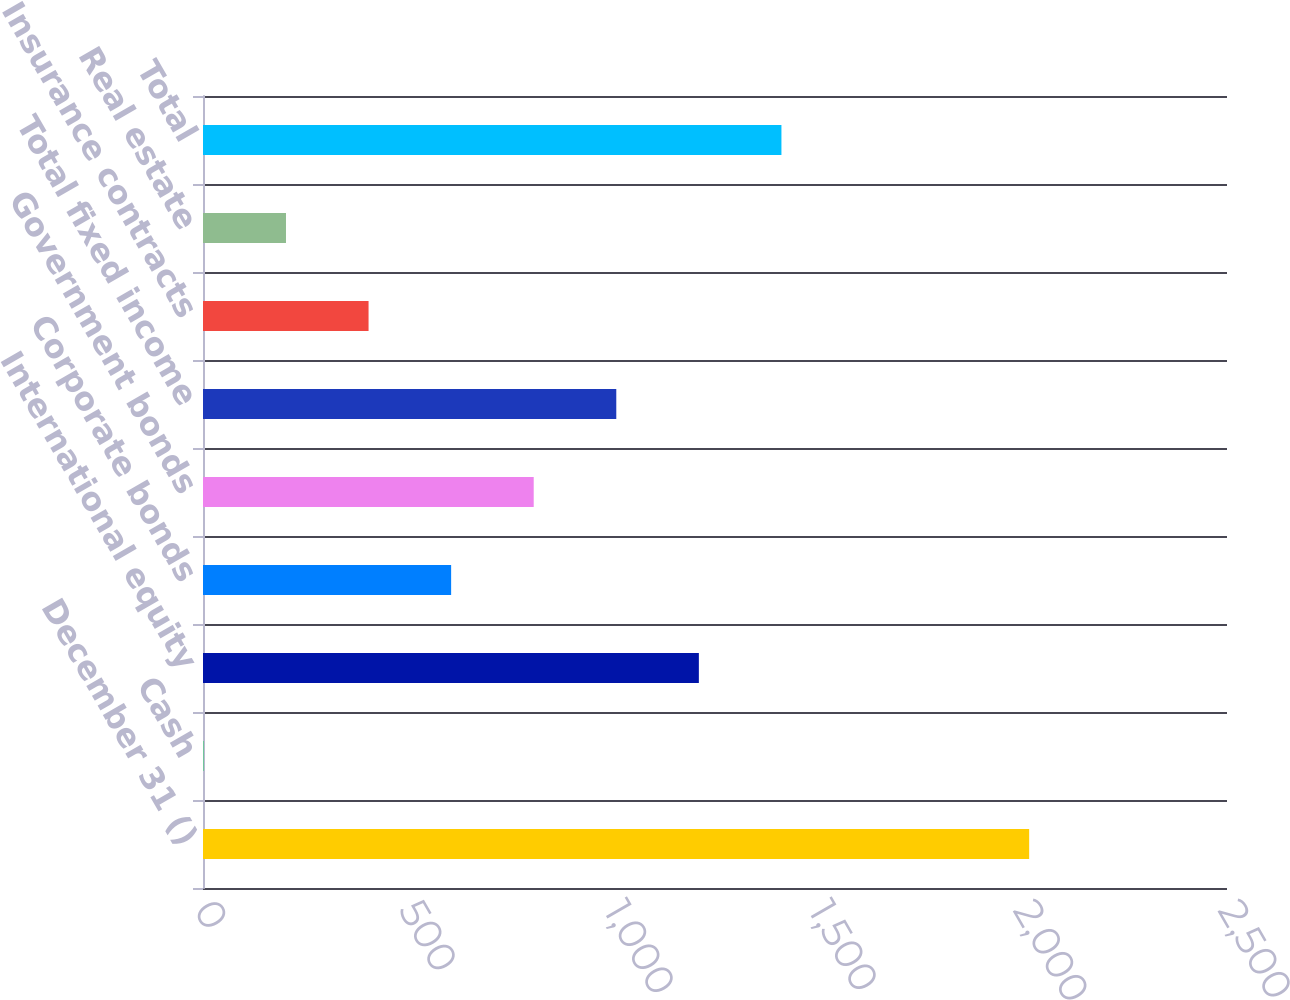<chart> <loc_0><loc_0><loc_500><loc_500><bar_chart><fcel>December 31 ()<fcel>Cash<fcel>International equity<fcel>Corporate bonds<fcel>Government bonds<fcel>Total fixed income<fcel>Insurance contracts<fcel>Real estate<fcel>Total<nl><fcel>2017<fcel>1<fcel>1210.6<fcel>605.8<fcel>807.4<fcel>1009<fcel>404.2<fcel>202.6<fcel>1412.2<nl></chart> 